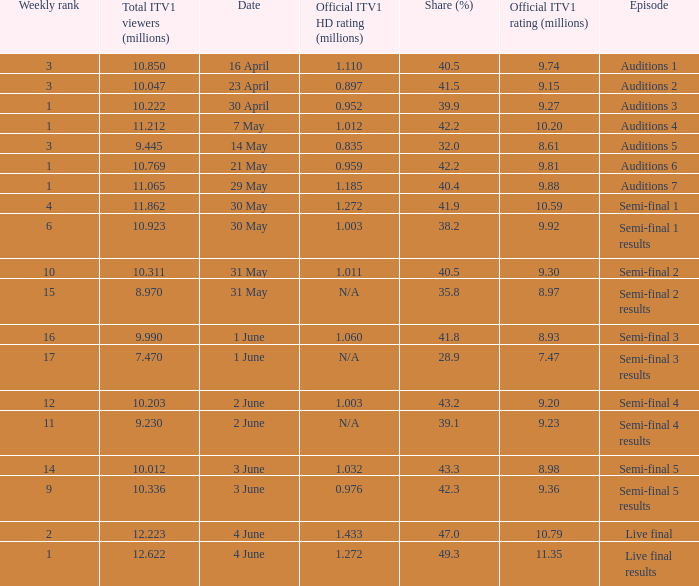When was the episode that had a share (%) of 41.5? 23 April. 